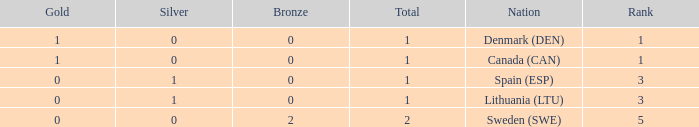What is the number of gold medals for Lithuania (ltu), when the total is more than 1? None. 